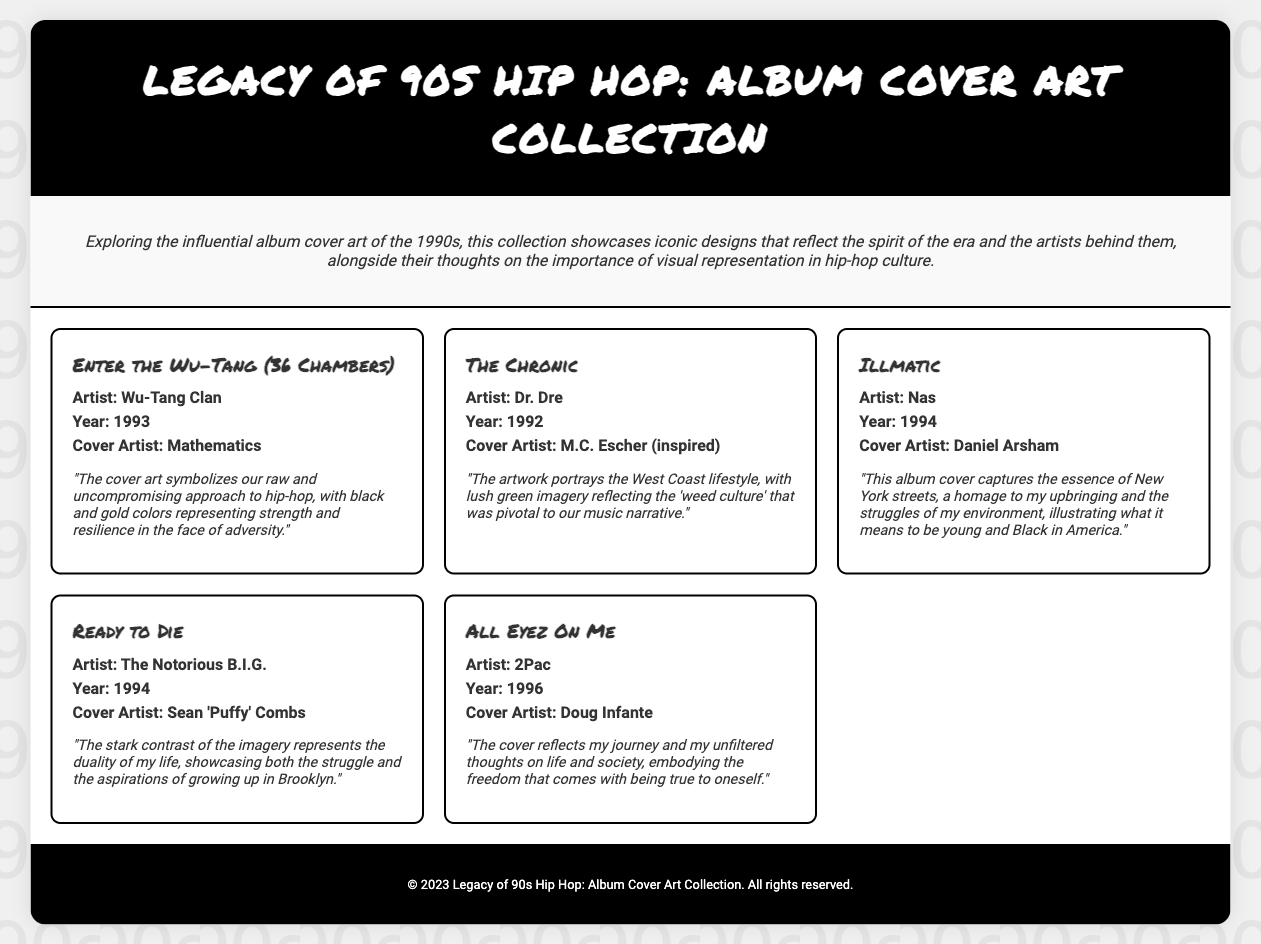What is the title of the first album featured? The title of the first album is listed in the album grid under the Wu-Tang Clan entry.
Answer: Enter the Wu-Tang (36 Chambers) Who is the artist of "Illmatic"? The artist of "Illmatic" is mentioned right below the album title within its respective album section.
Answer: Nas What year was "The Chronic" released? The year of release for "The Chronic" is specified in the album details, found below the album artist's name.
Answer: 1992 Who created the cover art for "Ready to Die"? The cover artist for "Ready to Die" is stated under the album details in that section.
Answer: Sean 'Puffy' Combs What is the main theme represented in the cover art of "All Eyez On Me"? The artist statement for "All Eyez On Me" describes the cover's representation of freedom and authenticity, which stands out as a theme.
Answer: Journey and unfiltered thoughts How many albums are included in the collection? The document lists the number of albums featured in the album grid, which can be counted directly.
Answer: Five What is the primary color scheme mentioned for the "Enter the Wu-Tang (36 Chambers)" cover? The artist statement for the album reveals details about the colors used in the cover art.
Answer: Black and gold Which artist is behind the cover art for "Illmatic"? The specific artist responsible for the cover art of "Illmatic" is mentioned distinctly in its album section.
Answer: Daniel Arsham What does the introduction highlight about the importance of visual representation? The introduction provides an overview of the document's theme, particularly emphasizing the spirit of the era and its visual aspect.
Answer: Visual representation in hip-hop culture 